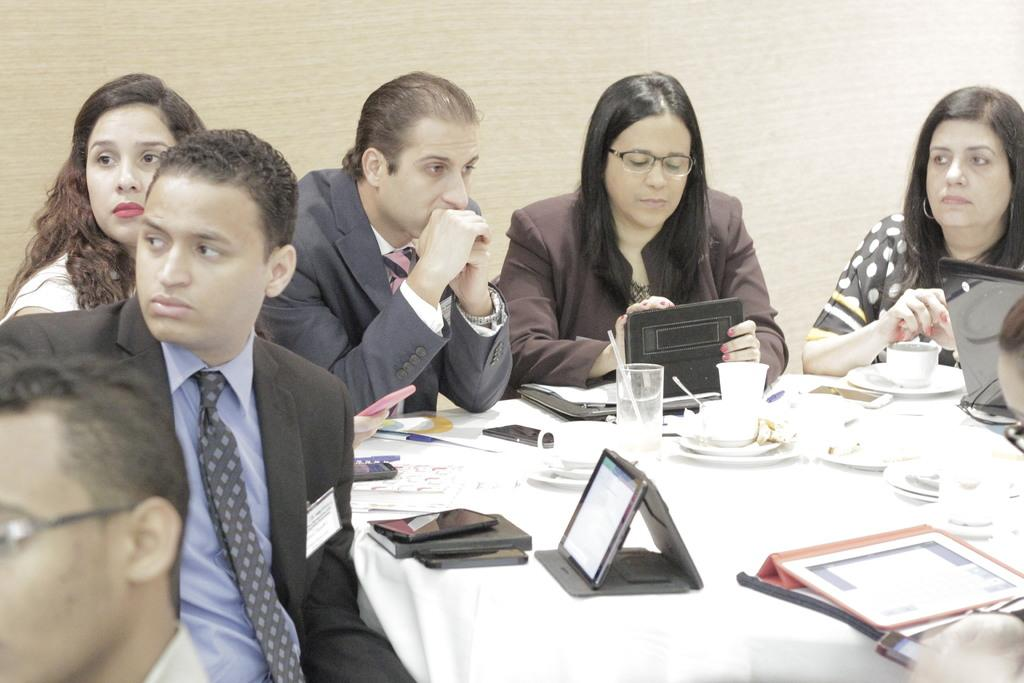What are the people in the image doing? The people in the image are sitting around the table. What electronic devices can be seen on the table? There are tablets, mobile phones, and a laptop on the table. What else is on the table besides electronic devices? There are glasses, papers, and cups on the table. What can be seen in the background of the image? There is a wall in the background of the image. What type of rice is being served on the table in the image? There is no rice present in the image; the table contains electronic devices, glasses, papers, and cups. 